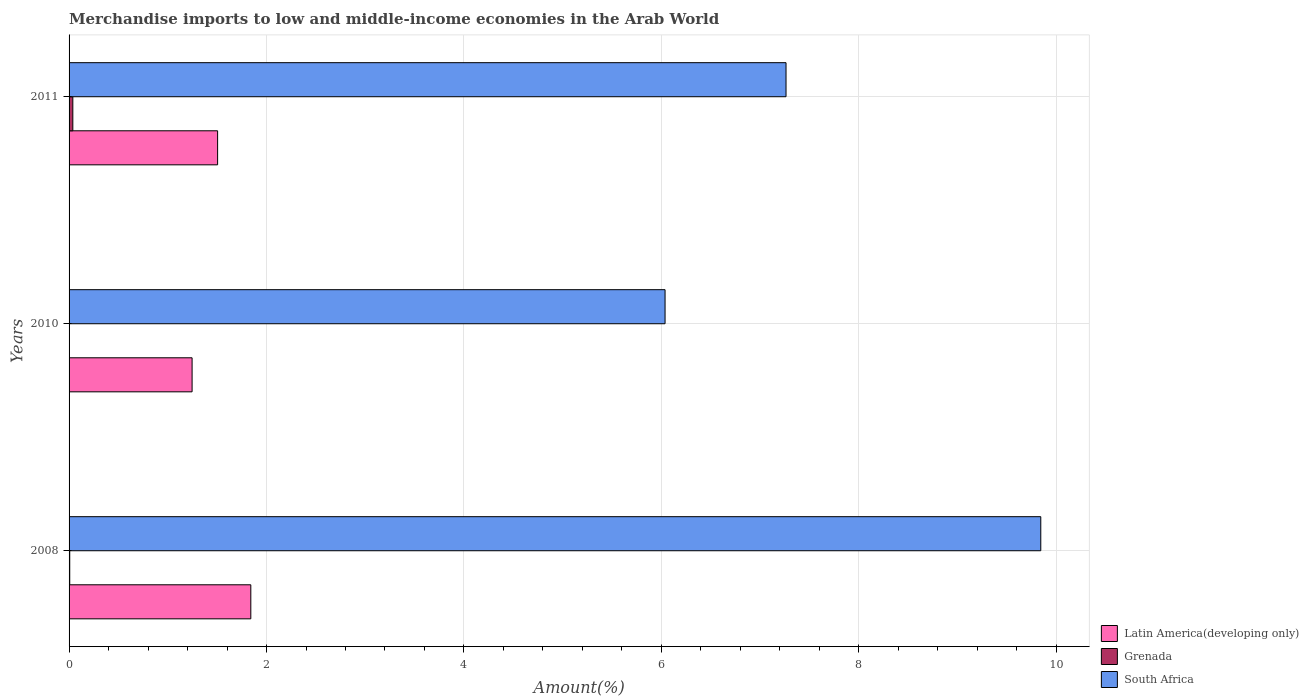In how many cases, is the number of bars for a given year not equal to the number of legend labels?
Provide a short and direct response. 0. What is the percentage of amount earned from merchandise imports in Latin America(developing only) in 2008?
Your answer should be compact. 1.84. Across all years, what is the maximum percentage of amount earned from merchandise imports in Grenada?
Offer a terse response. 0.04. Across all years, what is the minimum percentage of amount earned from merchandise imports in Latin America(developing only)?
Offer a terse response. 1.25. In which year was the percentage of amount earned from merchandise imports in Latin America(developing only) minimum?
Make the answer very short. 2010. What is the total percentage of amount earned from merchandise imports in South Africa in the graph?
Make the answer very short. 23.14. What is the difference between the percentage of amount earned from merchandise imports in Grenada in 2008 and that in 2010?
Provide a succinct answer. 0.01. What is the difference between the percentage of amount earned from merchandise imports in South Africa in 2011 and the percentage of amount earned from merchandise imports in Grenada in 2008?
Offer a terse response. 7.26. What is the average percentage of amount earned from merchandise imports in South Africa per year?
Offer a terse response. 7.71. In the year 2008, what is the difference between the percentage of amount earned from merchandise imports in South Africa and percentage of amount earned from merchandise imports in Latin America(developing only)?
Offer a terse response. 8. In how many years, is the percentage of amount earned from merchandise imports in Grenada greater than 1.6 %?
Provide a succinct answer. 0. What is the ratio of the percentage of amount earned from merchandise imports in Grenada in 2008 to that in 2011?
Offer a terse response. 0.18. Is the percentage of amount earned from merchandise imports in Latin America(developing only) in 2010 less than that in 2011?
Give a very brief answer. Yes. Is the difference between the percentage of amount earned from merchandise imports in South Africa in 2010 and 2011 greater than the difference between the percentage of amount earned from merchandise imports in Latin America(developing only) in 2010 and 2011?
Provide a short and direct response. No. What is the difference between the highest and the second highest percentage of amount earned from merchandise imports in Grenada?
Ensure brevity in your answer.  0.03. What is the difference between the highest and the lowest percentage of amount earned from merchandise imports in Grenada?
Provide a succinct answer. 0.04. In how many years, is the percentage of amount earned from merchandise imports in South Africa greater than the average percentage of amount earned from merchandise imports in South Africa taken over all years?
Your answer should be compact. 1. Is the sum of the percentage of amount earned from merchandise imports in Latin America(developing only) in 2008 and 2011 greater than the maximum percentage of amount earned from merchandise imports in Grenada across all years?
Make the answer very short. Yes. What does the 1st bar from the top in 2011 represents?
Your answer should be compact. South Africa. What does the 3rd bar from the bottom in 2011 represents?
Your answer should be compact. South Africa. Is it the case that in every year, the sum of the percentage of amount earned from merchandise imports in South Africa and percentage of amount earned from merchandise imports in Latin America(developing only) is greater than the percentage of amount earned from merchandise imports in Grenada?
Make the answer very short. Yes. Are all the bars in the graph horizontal?
Your answer should be very brief. Yes. Does the graph contain any zero values?
Make the answer very short. No. Does the graph contain grids?
Ensure brevity in your answer.  Yes. Where does the legend appear in the graph?
Ensure brevity in your answer.  Bottom right. How many legend labels are there?
Provide a succinct answer. 3. What is the title of the graph?
Keep it short and to the point. Merchandise imports to low and middle-income economies in the Arab World. Does "Swaziland" appear as one of the legend labels in the graph?
Offer a terse response. No. What is the label or title of the X-axis?
Your response must be concise. Amount(%). What is the label or title of the Y-axis?
Offer a terse response. Years. What is the Amount(%) of Latin America(developing only) in 2008?
Give a very brief answer. 1.84. What is the Amount(%) of Grenada in 2008?
Provide a short and direct response. 0.01. What is the Amount(%) of South Africa in 2008?
Offer a terse response. 9.84. What is the Amount(%) in Latin America(developing only) in 2010?
Offer a very short reply. 1.25. What is the Amount(%) of Grenada in 2010?
Your answer should be compact. 6.59134036777357e-5. What is the Amount(%) of South Africa in 2010?
Your answer should be very brief. 6.04. What is the Amount(%) of Latin America(developing only) in 2011?
Your response must be concise. 1.5. What is the Amount(%) in Grenada in 2011?
Keep it short and to the point. 0.04. What is the Amount(%) in South Africa in 2011?
Ensure brevity in your answer.  7.26. Across all years, what is the maximum Amount(%) of Latin America(developing only)?
Provide a succinct answer. 1.84. Across all years, what is the maximum Amount(%) in Grenada?
Keep it short and to the point. 0.04. Across all years, what is the maximum Amount(%) in South Africa?
Give a very brief answer. 9.84. Across all years, what is the minimum Amount(%) in Latin America(developing only)?
Your answer should be compact. 1.25. Across all years, what is the minimum Amount(%) of Grenada?
Give a very brief answer. 6.59134036777357e-5. Across all years, what is the minimum Amount(%) of South Africa?
Your response must be concise. 6.04. What is the total Amount(%) of Latin America(developing only) in the graph?
Your response must be concise. 4.59. What is the total Amount(%) of Grenada in the graph?
Ensure brevity in your answer.  0.04. What is the total Amount(%) in South Africa in the graph?
Provide a succinct answer. 23.14. What is the difference between the Amount(%) in Latin America(developing only) in 2008 and that in 2010?
Make the answer very short. 0.59. What is the difference between the Amount(%) in Grenada in 2008 and that in 2010?
Ensure brevity in your answer.  0.01. What is the difference between the Amount(%) of South Africa in 2008 and that in 2010?
Your response must be concise. 3.81. What is the difference between the Amount(%) of Latin America(developing only) in 2008 and that in 2011?
Your answer should be very brief. 0.34. What is the difference between the Amount(%) of Grenada in 2008 and that in 2011?
Offer a very short reply. -0.03. What is the difference between the Amount(%) in South Africa in 2008 and that in 2011?
Your answer should be very brief. 2.58. What is the difference between the Amount(%) of Latin America(developing only) in 2010 and that in 2011?
Offer a terse response. -0.26. What is the difference between the Amount(%) of Grenada in 2010 and that in 2011?
Your answer should be compact. -0.04. What is the difference between the Amount(%) of South Africa in 2010 and that in 2011?
Your response must be concise. -1.23. What is the difference between the Amount(%) in Latin America(developing only) in 2008 and the Amount(%) in Grenada in 2010?
Your response must be concise. 1.84. What is the difference between the Amount(%) of Latin America(developing only) in 2008 and the Amount(%) of South Africa in 2010?
Keep it short and to the point. -4.2. What is the difference between the Amount(%) of Grenada in 2008 and the Amount(%) of South Africa in 2010?
Give a very brief answer. -6.03. What is the difference between the Amount(%) of Latin America(developing only) in 2008 and the Amount(%) of Grenada in 2011?
Your answer should be compact. 1.8. What is the difference between the Amount(%) of Latin America(developing only) in 2008 and the Amount(%) of South Africa in 2011?
Provide a succinct answer. -5.42. What is the difference between the Amount(%) of Grenada in 2008 and the Amount(%) of South Africa in 2011?
Your answer should be compact. -7.26. What is the difference between the Amount(%) in Latin America(developing only) in 2010 and the Amount(%) in Grenada in 2011?
Offer a terse response. 1.21. What is the difference between the Amount(%) in Latin America(developing only) in 2010 and the Amount(%) in South Africa in 2011?
Make the answer very short. -6.02. What is the difference between the Amount(%) in Grenada in 2010 and the Amount(%) in South Africa in 2011?
Ensure brevity in your answer.  -7.26. What is the average Amount(%) in Latin America(developing only) per year?
Keep it short and to the point. 1.53. What is the average Amount(%) of Grenada per year?
Keep it short and to the point. 0.01. What is the average Amount(%) in South Africa per year?
Give a very brief answer. 7.71. In the year 2008, what is the difference between the Amount(%) in Latin America(developing only) and Amount(%) in Grenada?
Make the answer very short. 1.83. In the year 2008, what is the difference between the Amount(%) in Latin America(developing only) and Amount(%) in South Africa?
Your answer should be compact. -8. In the year 2008, what is the difference between the Amount(%) in Grenada and Amount(%) in South Africa?
Your answer should be compact. -9.84. In the year 2010, what is the difference between the Amount(%) in Latin America(developing only) and Amount(%) in Grenada?
Offer a very short reply. 1.25. In the year 2010, what is the difference between the Amount(%) of Latin America(developing only) and Amount(%) of South Africa?
Make the answer very short. -4.79. In the year 2010, what is the difference between the Amount(%) in Grenada and Amount(%) in South Africa?
Keep it short and to the point. -6.04. In the year 2011, what is the difference between the Amount(%) of Latin America(developing only) and Amount(%) of Grenada?
Keep it short and to the point. 1.47. In the year 2011, what is the difference between the Amount(%) of Latin America(developing only) and Amount(%) of South Africa?
Ensure brevity in your answer.  -5.76. In the year 2011, what is the difference between the Amount(%) in Grenada and Amount(%) in South Africa?
Provide a succinct answer. -7.22. What is the ratio of the Amount(%) of Latin America(developing only) in 2008 to that in 2010?
Your answer should be very brief. 1.48. What is the ratio of the Amount(%) in Grenada in 2008 to that in 2010?
Make the answer very short. 101.85. What is the ratio of the Amount(%) in South Africa in 2008 to that in 2010?
Keep it short and to the point. 1.63. What is the ratio of the Amount(%) in Latin America(developing only) in 2008 to that in 2011?
Give a very brief answer. 1.22. What is the ratio of the Amount(%) of Grenada in 2008 to that in 2011?
Keep it short and to the point. 0.18. What is the ratio of the Amount(%) of South Africa in 2008 to that in 2011?
Your answer should be very brief. 1.36. What is the ratio of the Amount(%) of Latin America(developing only) in 2010 to that in 2011?
Keep it short and to the point. 0.83. What is the ratio of the Amount(%) of Grenada in 2010 to that in 2011?
Provide a short and direct response. 0. What is the ratio of the Amount(%) in South Africa in 2010 to that in 2011?
Keep it short and to the point. 0.83. What is the difference between the highest and the second highest Amount(%) in Latin America(developing only)?
Your response must be concise. 0.34. What is the difference between the highest and the second highest Amount(%) in Grenada?
Your answer should be compact. 0.03. What is the difference between the highest and the second highest Amount(%) in South Africa?
Your answer should be very brief. 2.58. What is the difference between the highest and the lowest Amount(%) of Latin America(developing only)?
Your response must be concise. 0.59. What is the difference between the highest and the lowest Amount(%) in Grenada?
Your answer should be very brief. 0.04. What is the difference between the highest and the lowest Amount(%) in South Africa?
Your answer should be compact. 3.81. 